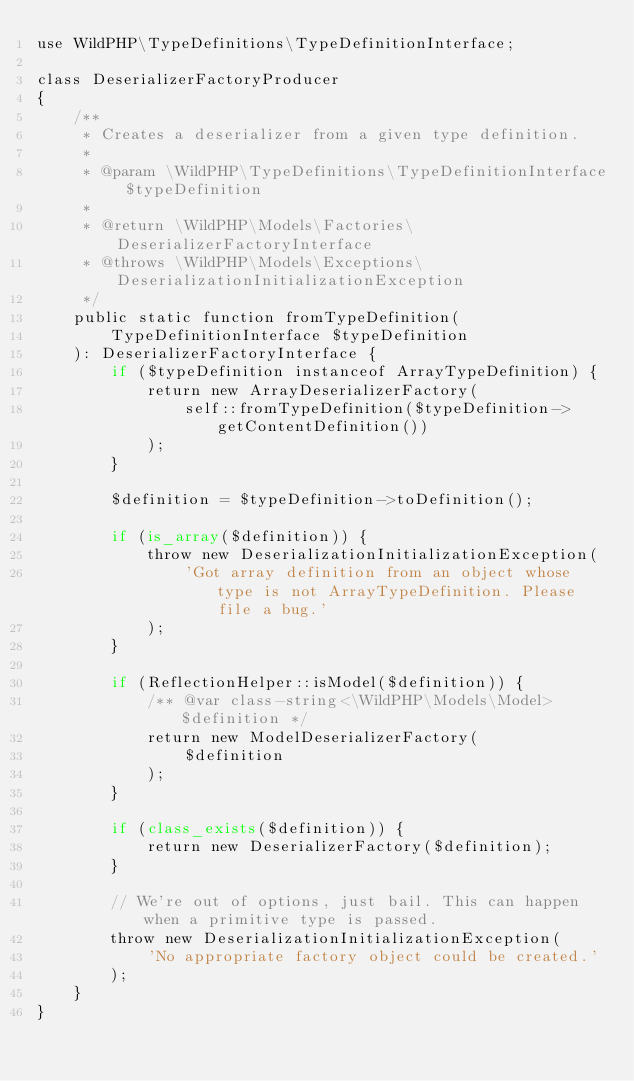Convert code to text. <code><loc_0><loc_0><loc_500><loc_500><_PHP_>use WildPHP\TypeDefinitions\TypeDefinitionInterface;

class DeserializerFactoryProducer
{
    /**
     * Creates a deserializer from a given type definition.
     *
     * @param \WildPHP\TypeDefinitions\TypeDefinitionInterface $typeDefinition
     *
     * @return \WildPHP\Models\Factories\DeserializerFactoryInterface
     * @throws \WildPHP\Models\Exceptions\DeserializationInitializationException
     */
    public static function fromTypeDefinition(
        TypeDefinitionInterface $typeDefinition
    ): DeserializerFactoryInterface {
        if ($typeDefinition instanceof ArrayTypeDefinition) {
            return new ArrayDeserializerFactory(
                self::fromTypeDefinition($typeDefinition->getContentDefinition())
            );
        }

        $definition = $typeDefinition->toDefinition();

        if (is_array($definition)) {
            throw new DeserializationInitializationException(
                'Got array definition from an object whose type is not ArrayTypeDefinition. Please file a bug.'
            );
        }

        if (ReflectionHelper::isModel($definition)) {
            /** @var class-string<\WildPHP\Models\Model> $definition */
            return new ModelDeserializerFactory(
                $definition
            );
        }

        if (class_exists($definition)) {
            return new DeserializerFactory($definition);
        }

        // We're out of options, just bail. This can happen when a primitive type is passed.
        throw new DeserializationInitializationException(
            'No appropriate factory object could be created.'
        );
    }
}
</code> 